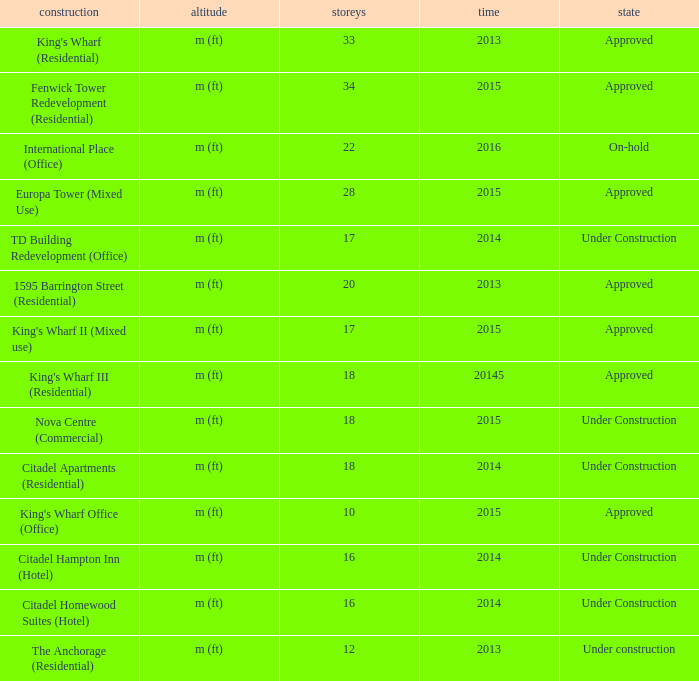What are the number of floors for the building of td building redevelopment (office)? 17.0. 